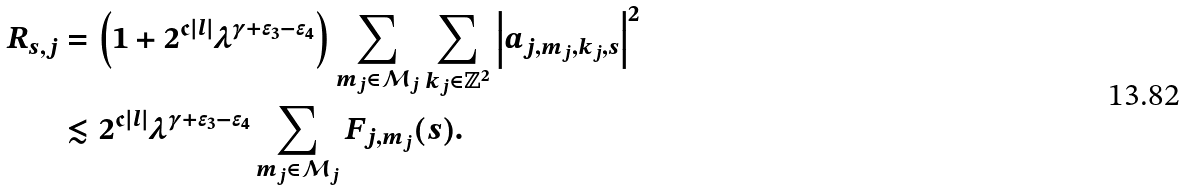Convert formula to latex. <formula><loc_0><loc_0><loc_500><loc_500>R _ { s , j } & = \left ( 1 + 2 ^ { \mathfrak { c } | l | } \lambda ^ { \gamma + \epsilon _ { 3 } - \epsilon _ { 4 } } \right ) \sum _ { m _ { j } \in \mathcal { M } _ { j } } \sum _ { k _ { j } \in \mathbb { Z } ^ { 2 } } \left | a _ { j , m _ { j } , k _ { j } , s } \right | ^ { 2 } \\ & \lesssim 2 ^ { \mathfrak { c } | l | } \lambda ^ { \gamma + \epsilon _ { 3 } - \epsilon _ { 4 } } \sum _ { m _ { j } \in \mathcal { M } _ { j } } F _ { j , m _ { j } } ( s ) .</formula> 